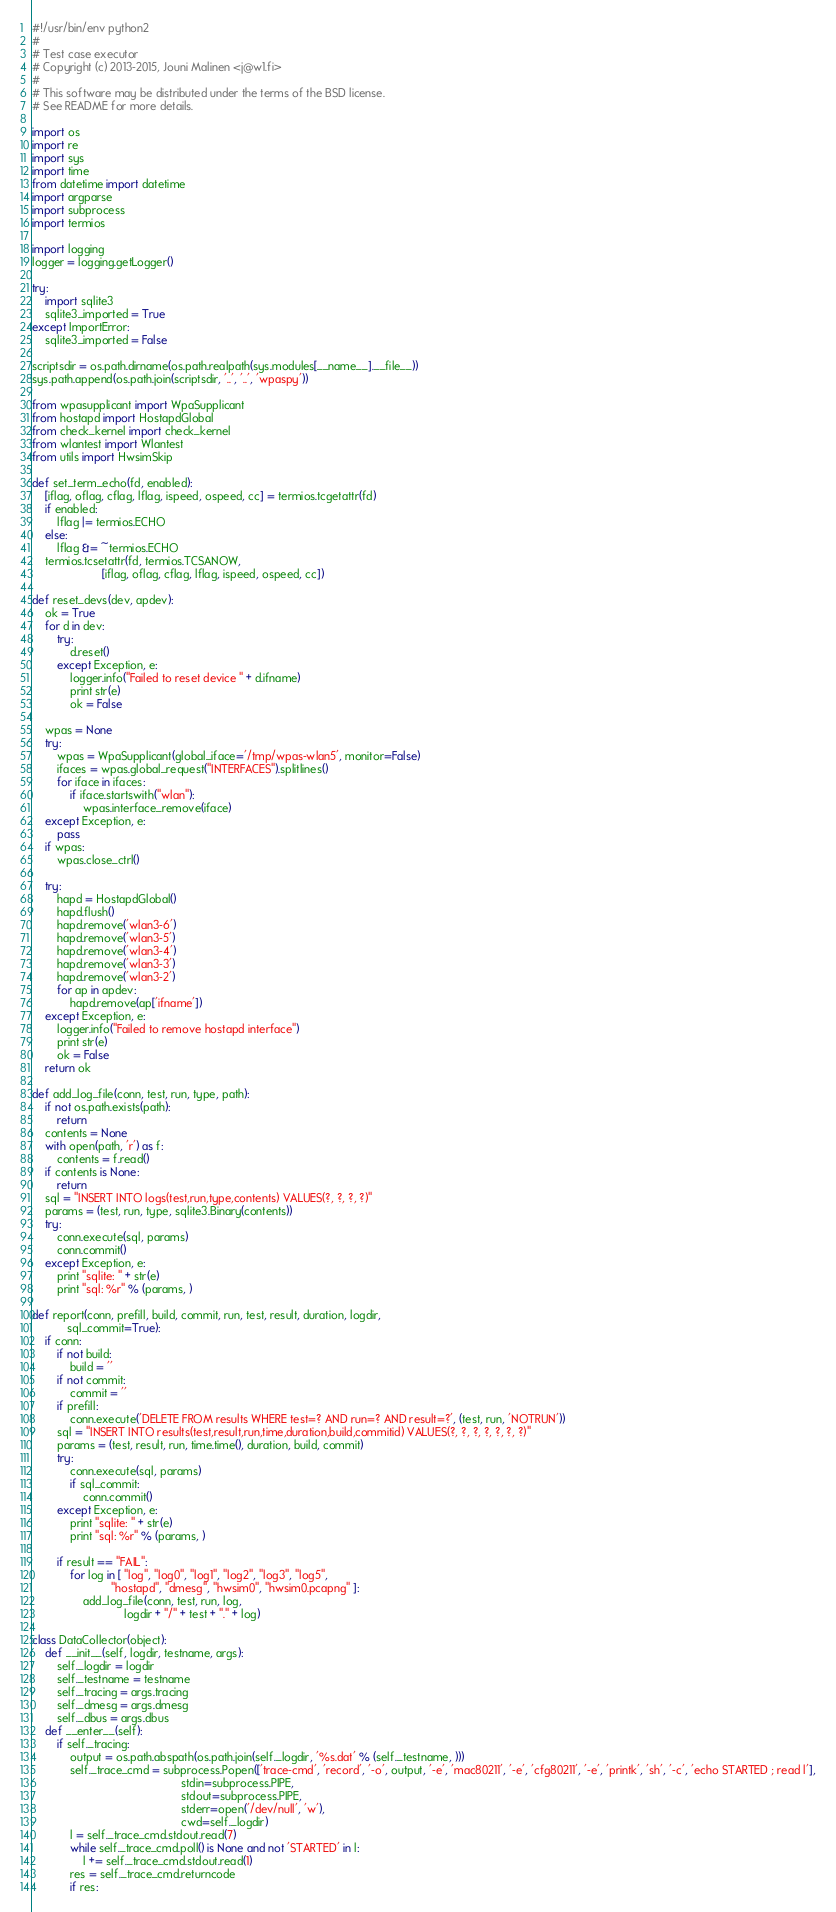Convert code to text. <code><loc_0><loc_0><loc_500><loc_500><_Python_>#!/usr/bin/env python2
#
# Test case executor
# Copyright (c) 2013-2015, Jouni Malinen <j@w1.fi>
#
# This software may be distributed under the terms of the BSD license.
# See README for more details.

import os
import re
import sys
import time
from datetime import datetime
import argparse
import subprocess
import termios

import logging
logger = logging.getLogger()

try:
    import sqlite3
    sqlite3_imported = True
except ImportError:
    sqlite3_imported = False

scriptsdir = os.path.dirname(os.path.realpath(sys.modules[__name__].__file__))
sys.path.append(os.path.join(scriptsdir, '..', '..', 'wpaspy'))

from wpasupplicant import WpaSupplicant
from hostapd import HostapdGlobal
from check_kernel import check_kernel
from wlantest import Wlantest
from utils import HwsimSkip

def set_term_echo(fd, enabled):
    [iflag, oflag, cflag, lflag, ispeed, ospeed, cc] = termios.tcgetattr(fd)
    if enabled:
        lflag |= termios.ECHO
    else:
        lflag &= ~termios.ECHO
    termios.tcsetattr(fd, termios.TCSANOW,
                      [iflag, oflag, cflag, lflag, ispeed, ospeed, cc])

def reset_devs(dev, apdev):
    ok = True
    for d in dev:
        try:
            d.reset()
        except Exception, e:
            logger.info("Failed to reset device " + d.ifname)
            print str(e)
            ok = False

    wpas = None
    try:
        wpas = WpaSupplicant(global_iface='/tmp/wpas-wlan5', monitor=False)
        ifaces = wpas.global_request("INTERFACES").splitlines()
        for iface in ifaces:
            if iface.startswith("wlan"):
                wpas.interface_remove(iface)
    except Exception, e:
        pass
    if wpas:
        wpas.close_ctrl()

    try:
        hapd = HostapdGlobal()
        hapd.flush()
        hapd.remove('wlan3-6')
        hapd.remove('wlan3-5')
        hapd.remove('wlan3-4')
        hapd.remove('wlan3-3')
        hapd.remove('wlan3-2')
        for ap in apdev:
            hapd.remove(ap['ifname'])
    except Exception, e:
        logger.info("Failed to remove hostapd interface")
        print str(e)
        ok = False
    return ok

def add_log_file(conn, test, run, type, path):
    if not os.path.exists(path):
        return
    contents = None
    with open(path, 'r') as f:
        contents = f.read()
    if contents is None:
        return
    sql = "INSERT INTO logs(test,run,type,contents) VALUES(?, ?, ?, ?)"
    params = (test, run, type, sqlite3.Binary(contents))
    try:
        conn.execute(sql, params)
        conn.commit()
    except Exception, e:
        print "sqlite: " + str(e)
        print "sql: %r" % (params, )

def report(conn, prefill, build, commit, run, test, result, duration, logdir,
           sql_commit=True):
    if conn:
        if not build:
            build = ''
        if not commit:
            commit = ''
        if prefill:
            conn.execute('DELETE FROM results WHERE test=? AND run=? AND result=?', (test, run, 'NOTRUN'))
        sql = "INSERT INTO results(test,result,run,time,duration,build,commitid) VALUES(?, ?, ?, ?, ?, ?, ?)"
        params = (test, result, run, time.time(), duration, build, commit)
        try:
            conn.execute(sql, params)
            if sql_commit:
                conn.commit()
        except Exception, e:
            print "sqlite: " + str(e)
            print "sql: %r" % (params, )

        if result == "FAIL":
            for log in [ "log", "log0", "log1", "log2", "log3", "log5",
                         "hostapd", "dmesg", "hwsim0", "hwsim0.pcapng" ]:
                add_log_file(conn, test, run, log,
                             logdir + "/" + test + "." + log)

class DataCollector(object):
    def __init__(self, logdir, testname, args):
        self._logdir = logdir
        self._testname = testname
        self._tracing = args.tracing
        self._dmesg = args.dmesg
        self._dbus = args.dbus
    def __enter__(self):
        if self._tracing:
            output = os.path.abspath(os.path.join(self._logdir, '%s.dat' % (self._testname, )))
            self._trace_cmd = subprocess.Popen(['trace-cmd', 'record', '-o', output, '-e', 'mac80211', '-e', 'cfg80211', '-e', 'printk', 'sh', '-c', 'echo STARTED ; read l'],
                                               stdin=subprocess.PIPE,
                                               stdout=subprocess.PIPE,
                                               stderr=open('/dev/null', 'w'),
                                               cwd=self._logdir)
            l = self._trace_cmd.stdout.read(7)
            while self._trace_cmd.poll() is None and not 'STARTED' in l:
                l += self._trace_cmd.stdout.read(1)
            res = self._trace_cmd.returncode
            if res:</code> 